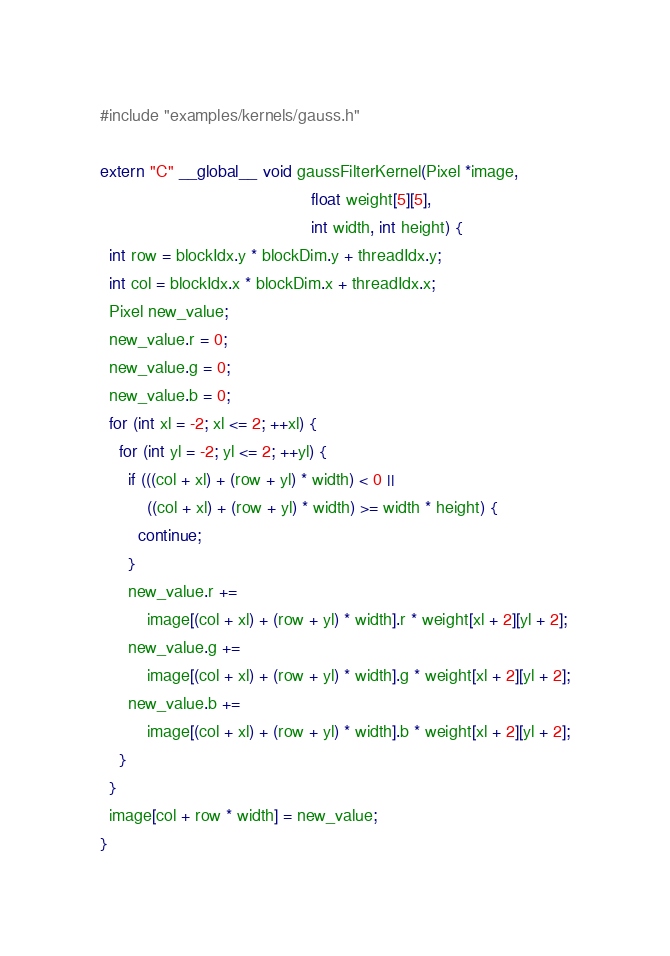Convert code to text. <code><loc_0><loc_0><loc_500><loc_500><_Cuda_>#include "examples/kernels/gauss.h"

extern "C" __global__ void gaussFilterKernel(Pixel *image,
                                             float weight[5][5],
                                             int width, int height) {
  int row = blockIdx.y * blockDim.y + threadIdx.y;
  int col = blockIdx.x * blockDim.x + threadIdx.x;
  Pixel new_value;
  new_value.r = 0;
  new_value.g = 0;
  new_value.b = 0;
  for (int xl = -2; xl <= 2; ++xl) {
    for (int yl = -2; yl <= 2; ++yl) {
      if (((col + xl) + (row + yl) * width) < 0 ||
          ((col + xl) + (row + yl) * width) >= width * height) {
        continue;
      }
      new_value.r +=
          image[(col + xl) + (row + yl) * width].r * weight[xl + 2][yl + 2];
      new_value.g +=
          image[(col + xl) + (row + yl) * width].g * weight[xl + 2][yl + 2];
      new_value.b +=
          image[(col + xl) + (row + yl) * width].b * weight[xl + 2][yl + 2];
    }
  }
  image[col + row * width] = new_value;
}</code> 